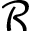<formula> <loc_0><loc_0><loc_500><loc_500>\mathcal { R }</formula> 